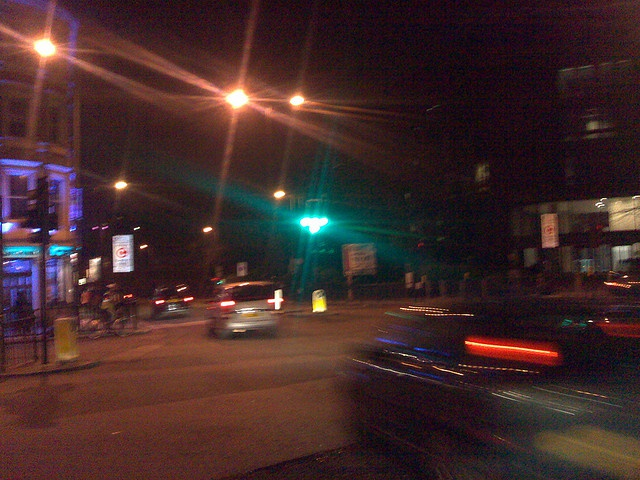Describe the objects in this image and their specific colors. I can see car in maroon, black, olive, and gray tones, car in maroon, gray, black, and tan tones, car in maroon, black, olive, and gray tones, people in maroon, black, navy, and purple tones, and bicycle in maroon, black, and purple tones in this image. 